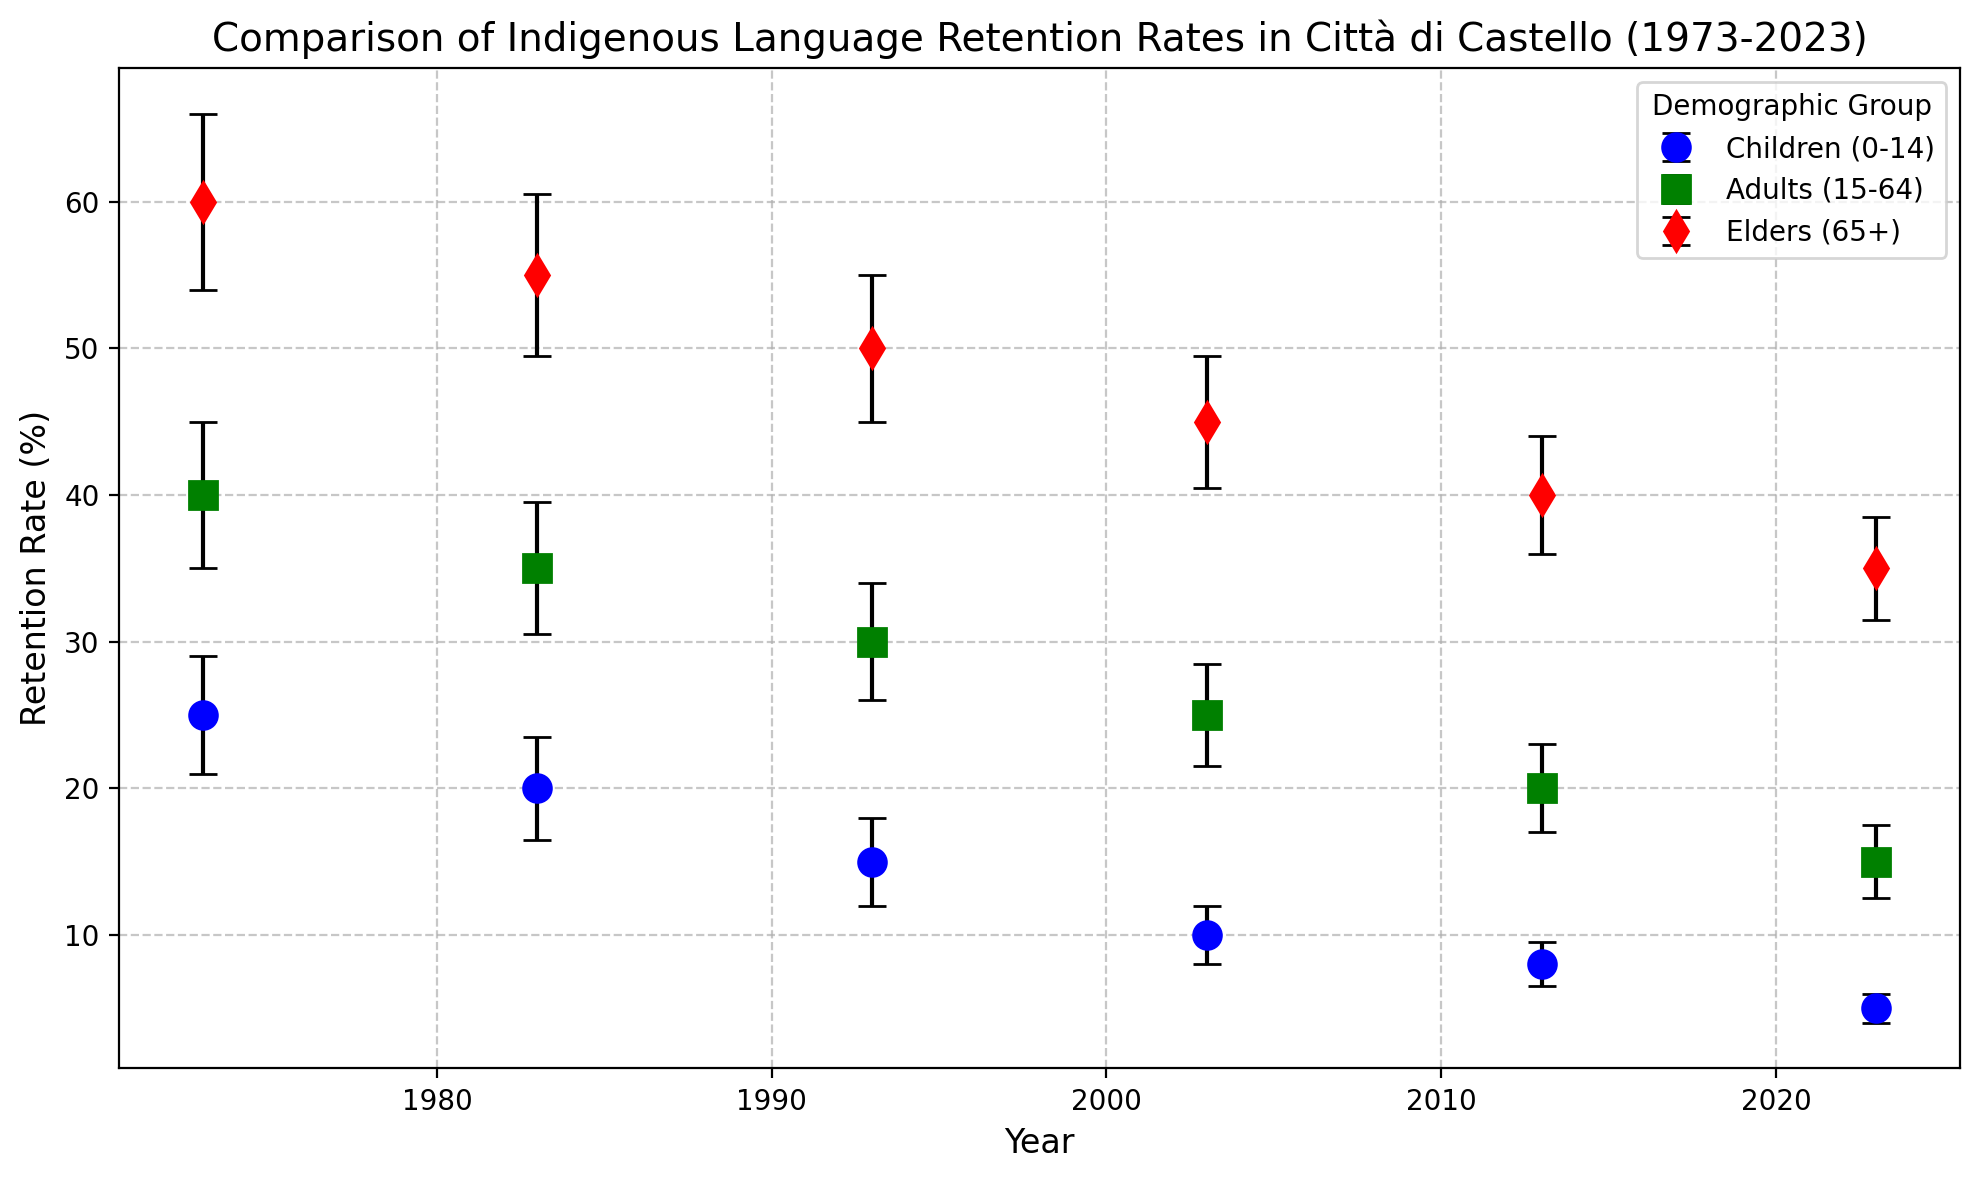What's the trend in the retention rate for children (0-14) from 1973 to 2023? The retention rate for children (0-14) shows a consistent downward trend from 25% in 1973 to 5% in 2023. This can be observed by looking at the blue line with circles on the graph, which decreases over time.
Answer: Downward trend Which demographic group had the highest retention rate in 1973? By examining the year 1973 on the x-axis and comparing the three data lines, the red line with diamonds for Elders (65+) has the highest retention rate at 60%.
Answer: Elders (65+) How has the retention rate changed for adults (15-64) from 1973 to 2023? The retention rate for adults (15-64) has decreased from 40% in 1973 to 15% in 2023. This can be seen by tracking the green line with squares on the graph from the leftmost point (1973) to the rightmost point (2023).
Answer: Decreased What is the difference in retention rates between elders (65+) and children (0-14) in 2023? In 2023, the retention rate for elders (65+) is 35%, and for children (0-14) is 5%. The difference is calculated as 35% - 5% = 30%.
Answer: 30% Which group experienced the smallest decline in retention rate from 1973 to 2023? By comparing the initial and final retention rates of each demographic group, Elders (65+) decreased from 60% to 35%, which is a 25% decline. Children (0-14) and Adults (15-64) experienced larger declines.
Answer: Elders (65+) In which year did adults (15-64) have the same retention rate as the retention rate for children (0-14) in 1973? Children (0-14) had a retention rate of 25% in 1973. The adults (15-64) also had a retention rate of 25% in 2003. This can be seen by comparing the data points of adults and children at those respective years.
Answer: 2003 What visual attribute differentiates the data for elders (65+) from other groups? The data for elders (65+) is represented with a red line and diamond markers, differentiating it from the blue circles of children (0-14) and the green squares of adults (15-64).
Answer: Red line and diamond markers Consider the standard error for children (0-14) in 1983. What is the highest possible retention rate considering this error? The retention rate for children (0-14) in 1983 is 20%, with a standard error of ±3.5%. The highest possible retention rate is 20% + 3.5% = 23.5%.
Answer: 23.5% Which year shows the largest standard error for any demographic group, and which group does it belong to? The largest standard error is 6% for Elders (65+) in 1973. This can be identified by comparing the vertical error bars on the graph.
Answer: 1973, Elders (65+) Comparing adults (15-64) in 1983 and elders (65+) in 2023, which group had a higher retention rate, and what was the difference? Adults (15-64) had a retention rate of 35% in 1983, and Elders (65+) had a retention rate of 35% in 2023, thus the retention rates are equal, and the difference is 0%.
Answer: Equal, 0% 